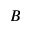Convert formula to latex. <formula><loc_0><loc_0><loc_500><loc_500>B</formula> 